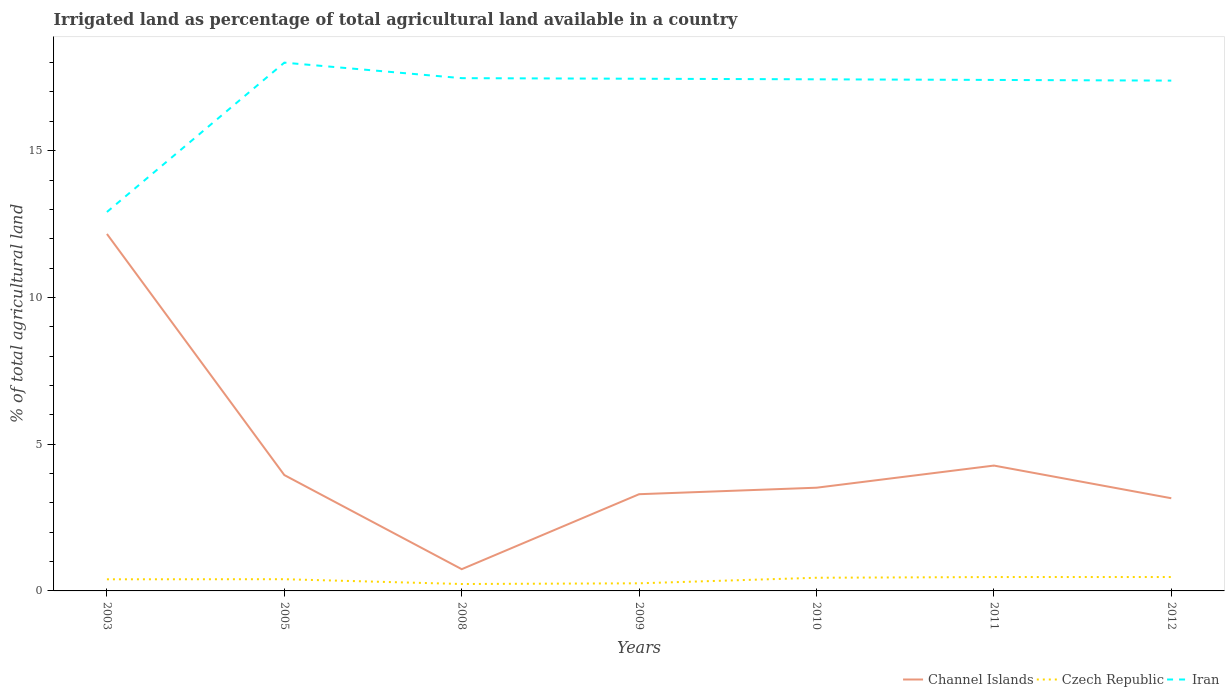Does the line corresponding to Czech Republic intersect with the line corresponding to Channel Islands?
Offer a terse response. No. Across all years, what is the maximum percentage of irrigated land in Czech Republic?
Provide a short and direct response. 0.24. In which year was the percentage of irrigated land in Channel Islands maximum?
Your response must be concise. 2008. What is the total percentage of irrigated land in Channel Islands in the graph?
Your response must be concise. -2.55. What is the difference between the highest and the second highest percentage of irrigated land in Czech Republic?
Provide a succinct answer. 0.24. Is the percentage of irrigated land in Czech Republic strictly greater than the percentage of irrigated land in Iran over the years?
Offer a very short reply. Yes. How many lines are there?
Offer a very short reply. 3. What is the difference between two consecutive major ticks on the Y-axis?
Provide a succinct answer. 5. Does the graph contain grids?
Your response must be concise. No. How many legend labels are there?
Offer a very short reply. 3. How are the legend labels stacked?
Offer a terse response. Horizontal. What is the title of the graph?
Your answer should be compact. Irrigated land as percentage of total agricultural land available in a country. Does "Morocco" appear as one of the legend labels in the graph?
Provide a short and direct response. No. What is the label or title of the Y-axis?
Offer a terse response. % of total agricultural land. What is the % of total agricultural land of Channel Islands in 2003?
Ensure brevity in your answer.  12.16. What is the % of total agricultural land in Czech Republic in 2003?
Provide a short and direct response. 0.4. What is the % of total agricultural land of Iran in 2003?
Your answer should be very brief. 12.91. What is the % of total agricultural land in Channel Islands in 2005?
Give a very brief answer. 3.95. What is the % of total agricultural land in Czech Republic in 2005?
Your answer should be compact. 0.4. What is the % of total agricultural land in Iran in 2005?
Provide a short and direct response. 18. What is the % of total agricultural land of Channel Islands in 2008?
Ensure brevity in your answer.  0.74. What is the % of total agricultural land in Czech Republic in 2008?
Give a very brief answer. 0.24. What is the % of total agricultural land of Iran in 2008?
Ensure brevity in your answer.  17.47. What is the % of total agricultural land in Channel Islands in 2009?
Ensure brevity in your answer.  3.3. What is the % of total agricultural land in Czech Republic in 2009?
Keep it short and to the point. 0.26. What is the % of total agricultural land in Iran in 2009?
Your response must be concise. 17.45. What is the % of total agricultural land of Channel Islands in 2010?
Keep it short and to the point. 3.52. What is the % of total agricultural land in Czech Republic in 2010?
Offer a very short reply. 0.45. What is the % of total agricultural land in Iran in 2010?
Provide a succinct answer. 17.43. What is the % of total agricultural land in Channel Islands in 2011?
Provide a short and direct response. 4.27. What is the % of total agricultural land of Czech Republic in 2011?
Your answer should be very brief. 0.47. What is the % of total agricultural land in Iran in 2011?
Ensure brevity in your answer.  17.41. What is the % of total agricultural land of Channel Islands in 2012?
Your answer should be compact. 3.16. What is the % of total agricultural land in Czech Republic in 2012?
Provide a succinct answer. 0.47. What is the % of total agricultural land in Iran in 2012?
Give a very brief answer. 17.39. Across all years, what is the maximum % of total agricultural land of Channel Islands?
Keep it short and to the point. 12.16. Across all years, what is the maximum % of total agricultural land of Czech Republic?
Your answer should be very brief. 0.47. Across all years, what is the maximum % of total agricultural land in Iran?
Ensure brevity in your answer.  18. Across all years, what is the minimum % of total agricultural land of Channel Islands?
Offer a terse response. 0.74. Across all years, what is the minimum % of total agricultural land of Czech Republic?
Your response must be concise. 0.24. Across all years, what is the minimum % of total agricultural land in Iran?
Offer a very short reply. 12.91. What is the total % of total agricultural land of Channel Islands in the graph?
Your response must be concise. 31.09. What is the total % of total agricultural land in Czech Republic in the graph?
Keep it short and to the point. 2.69. What is the total % of total agricultural land in Iran in the graph?
Offer a very short reply. 118.06. What is the difference between the % of total agricultural land of Channel Islands in 2003 and that in 2005?
Make the answer very short. 8.21. What is the difference between the % of total agricultural land of Czech Republic in 2003 and that in 2005?
Your answer should be compact. -0. What is the difference between the % of total agricultural land of Iran in 2003 and that in 2005?
Ensure brevity in your answer.  -5.09. What is the difference between the % of total agricultural land in Channel Islands in 2003 and that in 2008?
Ensure brevity in your answer.  11.42. What is the difference between the % of total agricultural land in Czech Republic in 2003 and that in 2008?
Keep it short and to the point. 0.16. What is the difference between the % of total agricultural land of Iran in 2003 and that in 2008?
Give a very brief answer. -4.56. What is the difference between the % of total agricultural land in Channel Islands in 2003 and that in 2009?
Ensure brevity in your answer.  8.87. What is the difference between the % of total agricultural land in Czech Republic in 2003 and that in 2009?
Give a very brief answer. 0.14. What is the difference between the % of total agricultural land in Iran in 2003 and that in 2009?
Provide a succinct answer. -4.54. What is the difference between the % of total agricultural land of Channel Islands in 2003 and that in 2010?
Ensure brevity in your answer.  8.65. What is the difference between the % of total agricultural land of Czech Republic in 2003 and that in 2010?
Your answer should be very brief. -0.05. What is the difference between the % of total agricultural land of Iran in 2003 and that in 2010?
Your response must be concise. -4.52. What is the difference between the % of total agricultural land of Channel Islands in 2003 and that in 2011?
Make the answer very short. 7.89. What is the difference between the % of total agricultural land in Czech Republic in 2003 and that in 2011?
Give a very brief answer. -0.08. What is the difference between the % of total agricultural land of Iran in 2003 and that in 2011?
Ensure brevity in your answer.  -4.5. What is the difference between the % of total agricultural land in Channel Islands in 2003 and that in 2012?
Offer a very short reply. 9. What is the difference between the % of total agricultural land in Czech Republic in 2003 and that in 2012?
Provide a succinct answer. -0.08. What is the difference between the % of total agricultural land in Iran in 2003 and that in 2012?
Provide a short and direct response. -4.48. What is the difference between the % of total agricultural land in Channel Islands in 2005 and that in 2008?
Provide a succinct answer. 3.21. What is the difference between the % of total agricultural land in Czech Republic in 2005 and that in 2008?
Make the answer very short. 0.16. What is the difference between the % of total agricultural land in Iran in 2005 and that in 2008?
Ensure brevity in your answer.  0.53. What is the difference between the % of total agricultural land of Channel Islands in 2005 and that in 2009?
Give a very brief answer. 0.65. What is the difference between the % of total agricultural land in Czech Republic in 2005 and that in 2009?
Provide a succinct answer. 0.14. What is the difference between the % of total agricultural land in Iran in 2005 and that in 2009?
Provide a succinct answer. 0.55. What is the difference between the % of total agricultural land in Channel Islands in 2005 and that in 2010?
Your answer should be compact. 0.43. What is the difference between the % of total agricultural land of Czech Republic in 2005 and that in 2010?
Give a very brief answer. -0.05. What is the difference between the % of total agricultural land of Iran in 2005 and that in 2010?
Keep it short and to the point. 0.57. What is the difference between the % of total agricultural land in Channel Islands in 2005 and that in 2011?
Offer a terse response. -0.32. What is the difference between the % of total agricultural land of Czech Republic in 2005 and that in 2011?
Offer a very short reply. -0.07. What is the difference between the % of total agricultural land in Iran in 2005 and that in 2011?
Your answer should be very brief. 0.59. What is the difference between the % of total agricultural land of Channel Islands in 2005 and that in 2012?
Ensure brevity in your answer.  0.79. What is the difference between the % of total agricultural land of Czech Republic in 2005 and that in 2012?
Give a very brief answer. -0.07. What is the difference between the % of total agricultural land in Iran in 2005 and that in 2012?
Offer a terse response. 0.61. What is the difference between the % of total agricultural land of Channel Islands in 2008 and that in 2009?
Make the answer very short. -2.55. What is the difference between the % of total agricultural land of Czech Republic in 2008 and that in 2009?
Offer a terse response. -0.02. What is the difference between the % of total agricultural land in Iran in 2008 and that in 2009?
Offer a terse response. 0.02. What is the difference between the % of total agricultural land of Channel Islands in 2008 and that in 2010?
Your answer should be compact. -2.78. What is the difference between the % of total agricultural land of Czech Republic in 2008 and that in 2010?
Give a very brief answer. -0.21. What is the difference between the % of total agricultural land in Iran in 2008 and that in 2010?
Make the answer very short. 0.04. What is the difference between the % of total agricultural land of Channel Islands in 2008 and that in 2011?
Provide a short and direct response. -3.53. What is the difference between the % of total agricultural land in Czech Republic in 2008 and that in 2011?
Offer a terse response. -0.24. What is the difference between the % of total agricultural land of Iran in 2008 and that in 2011?
Your answer should be very brief. 0.06. What is the difference between the % of total agricultural land in Channel Islands in 2008 and that in 2012?
Provide a short and direct response. -2.42. What is the difference between the % of total agricultural land of Czech Republic in 2008 and that in 2012?
Keep it short and to the point. -0.24. What is the difference between the % of total agricultural land in Iran in 2008 and that in 2012?
Your answer should be compact. 0.08. What is the difference between the % of total agricultural land of Channel Islands in 2009 and that in 2010?
Make the answer very short. -0.22. What is the difference between the % of total agricultural land in Czech Republic in 2009 and that in 2010?
Offer a very short reply. -0.19. What is the difference between the % of total agricultural land in Iran in 2009 and that in 2010?
Provide a short and direct response. 0.02. What is the difference between the % of total agricultural land of Channel Islands in 2009 and that in 2011?
Give a very brief answer. -0.98. What is the difference between the % of total agricultural land in Czech Republic in 2009 and that in 2011?
Provide a short and direct response. -0.21. What is the difference between the % of total agricultural land of Iran in 2009 and that in 2011?
Give a very brief answer. 0.04. What is the difference between the % of total agricultural land of Channel Islands in 2009 and that in 2012?
Keep it short and to the point. 0.14. What is the difference between the % of total agricultural land in Czech Republic in 2009 and that in 2012?
Give a very brief answer. -0.21. What is the difference between the % of total agricultural land of Iran in 2009 and that in 2012?
Offer a very short reply. 0.06. What is the difference between the % of total agricultural land of Channel Islands in 2010 and that in 2011?
Your answer should be compact. -0.75. What is the difference between the % of total agricultural land of Czech Republic in 2010 and that in 2011?
Offer a very short reply. -0.02. What is the difference between the % of total agricultural land in Iran in 2010 and that in 2011?
Offer a terse response. 0.02. What is the difference between the % of total agricultural land in Channel Islands in 2010 and that in 2012?
Offer a very short reply. 0.36. What is the difference between the % of total agricultural land in Czech Republic in 2010 and that in 2012?
Keep it short and to the point. -0.02. What is the difference between the % of total agricultural land in Iran in 2010 and that in 2012?
Ensure brevity in your answer.  0.04. What is the difference between the % of total agricultural land of Channel Islands in 2011 and that in 2012?
Offer a terse response. 1.11. What is the difference between the % of total agricultural land of Czech Republic in 2011 and that in 2012?
Offer a terse response. -0. What is the difference between the % of total agricultural land of Iran in 2011 and that in 2012?
Your response must be concise. 0.02. What is the difference between the % of total agricultural land of Channel Islands in 2003 and the % of total agricultural land of Czech Republic in 2005?
Keep it short and to the point. 11.76. What is the difference between the % of total agricultural land of Channel Islands in 2003 and the % of total agricultural land of Iran in 2005?
Keep it short and to the point. -5.84. What is the difference between the % of total agricultural land in Czech Republic in 2003 and the % of total agricultural land in Iran in 2005?
Your response must be concise. -17.6. What is the difference between the % of total agricultural land in Channel Islands in 2003 and the % of total agricultural land in Czech Republic in 2008?
Make the answer very short. 11.93. What is the difference between the % of total agricultural land in Channel Islands in 2003 and the % of total agricultural land in Iran in 2008?
Offer a very short reply. -5.31. What is the difference between the % of total agricultural land of Czech Republic in 2003 and the % of total agricultural land of Iran in 2008?
Offer a very short reply. -17.07. What is the difference between the % of total agricultural land in Channel Islands in 2003 and the % of total agricultural land in Czech Republic in 2009?
Give a very brief answer. 11.9. What is the difference between the % of total agricultural land in Channel Islands in 2003 and the % of total agricultural land in Iran in 2009?
Offer a very short reply. -5.29. What is the difference between the % of total agricultural land in Czech Republic in 2003 and the % of total agricultural land in Iran in 2009?
Offer a very short reply. -17.05. What is the difference between the % of total agricultural land in Channel Islands in 2003 and the % of total agricultural land in Czech Republic in 2010?
Your answer should be very brief. 11.71. What is the difference between the % of total agricultural land in Channel Islands in 2003 and the % of total agricultural land in Iran in 2010?
Provide a succinct answer. -5.27. What is the difference between the % of total agricultural land in Czech Republic in 2003 and the % of total agricultural land in Iran in 2010?
Provide a short and direct response. -17.04. What is the difference between the % of total agricultural land of Channel Islands in 2003 and the % of total agricultural land of Czech Republic in 2011?
Your answer should be very brief. 11.69. What is the difference between the % of total agricultural land of Channel Islands in 2003 and the % of total agricultural land of Iran in 2011?
Provide a succinct answer. -5.25. What is the difference between the % of total agricultural land in Czech Republic in 2003 and the % of total agricultural land in Iran in 2011?
Ensure brevity in your answer.  -17.01. What is the difference between the % of total agricultural land in Channel Islands in 2003 and the % of total agricultural land in Czech Republic in 2012?
Offer a very short reply. 11.69. What is the difference between the % of total agricultural land in Channel Islands in 2003 and the % of total agricultural land in Iran in 2012?
Ensure brevity in your answer.  -5.22. What is the difference between the % of total agricultural land of Czech Republic in 2003 and the % of total agricultural land of Iran in 2012?
Provide a succinct answer. -16.99. What is the difference between the % of total agricultural land in Channel Islands in 2005 and the % of total agricultural land in Czech Republic in 2008?
Your answer should be compact. 3.71. What is the difference between the % of total agricultural land of Channel Islands in 2005 and the % of total agricultural land of Iran in 2008?
Your answer should be compact. -13.52. What is the difference between the % of total agricultural land in Czech Republic in 2005 and the % of total agricultural land in Iran in 2008?
Provide a succinct answer. -17.07. What is the difference between the % of total agricultural land of Channel Islands in 2005 and the % of total agricultural land of Czech Republic in 2009?
Provide a short and direct response. 3.69. What is the difference between the % of total agricultural land of Channel Islands in 2005 and the % of total agricultural land of Iran in 2009?
Your answer should be very brief. -13.5. What is the difference between the % of total agricultural land in Czech Republic in 2005 and the % of total agricultural land in Iran in 2009?
Your response must be concise. -17.05. What is the difference between the % of total agricultural land in Channel Islands in 2005 and the % of total agricultural land in Czech Republic in 2010?
Offer a very short reply. 3.5. What is the difference between the % of total agricultural land of Channel Islands in 2005 and the % of total agricultural land of Iran in 2010?
Your response must be concise. -13.48. What is the difference between the % of total agricultural land in Czech Republic in 2005 and the % of total agricultural land in Iran in 2010?
Provide a short and direct response. -17.03. What is the difference between the % of total agricultural land of Channel Islands in 2005 and the % of total agricultural land of Czech Republic in 2011?
Make the answer very short. 3.47. What is the difference between the % of total agricultural land of Channel Islands in 2005 and the % of total agricultural land of Iran in 2011?
Provide a short and direct response. -13.46. What is the difference between the % of total agricultural land of Czech Republic in 2005 and the % of total agricultural land of Iran in 2011?
Your response must be concise. -17.01. What is the difference between the % of total agricultural land of Channel Islands in 2005 and the % of total agricultural land of Czech Republic in 2012?
Provide a short and direct response. 3.47. What is the difference between the % of total agricultural land of Channel Islands in 2005 and the % of total agricultural land of Iran in 2012?
Your answer should be compact. -13.44. What is the difference between the % of total agricultural land of Czech Republic in 2005 and the % of total agricultural land of Iran in 2012?
Offer a very short reply. -16.99. What is the difference between the % of total agricultural land in Channel Islands in 2008 and the % of total agricultural land in Czech Republic in 2009?
Your answer should be very brief. 0.48. What is the difference between the % of total agricultural land in Channel Islands in 2008 and the % of total agricultural land in Iran in 2009?
Make the answer very short. -16.71. What is the difference between the % of total agricultural land of Czech Republic in 2008 and the % of total agricultural land of Iran in 2009?
Provide a short and direct response. -17.21. What is the difference between the % of total agricultural land in Channel Islands in 2008 and the % of total agricultural land in Czech Republic in 2010?
Your answer should be compact. 0.29. What is the difference between the % of total agricultural land in Channel Islands in 2008 and the % of total agricultural land in Iran in 2010?
Provide a short and direct response. -16.69. What is the difference between the % of total agricultural land in Czech Republic in 2008 and the % of total agricultural land in Iran in 2010?
Ensure brevity in your answer.  -17.2. What is the difference between the % of total agricultural land of Channel Islands in 2008 and the % of total agricultural land of Czech Republic in 2011?
Keep it short and to the point. 0.27. What is the difference between the % of total agricultural land of Channel Islands in 2008 and the % of total agricultural land of Iran in 2011?
Your response must be concise. -16.67. What is the difference between the % of total agricultural land of Czech Republic in 2008 and the % of total agricultural land of Iran in 2011?
Your answer should be very brief. -17.17. What is the difference between the % of total agricultural land in Channel Islands in 2008 and the % of total agricultural land in Czech Republic in 2012?
Your response must be concise. 0.27. What is the difference between the % of total agricultural land in Channel Islands in 2008 and the % of total agricultural land in Iran in 2012?
Keep it short and to the point. -16.65. What is the difference between the % of total agricultural land of Czech Republic in 2008 and the % of total agricultural land of Iran in 2012?
Provide a succinct answer. -17.15. What is the difference between the % of total agricultural land of Channel Islands in 2009 and the % of total agricultural land of Czech Republic in 2010?
Ensure brevity in your answer.  2.85. What is the difference between the % of total agricultural land in Channel Islands in 2009 and the % of total agricultural land in Iran in 2010?
Ensure brevity in your answer.  -14.14. What is the difference between the % of total agricultural land of Czech Republic in 2009 and the % of total agricultural land of Iran in 2010?
Ensure brevity in your answer.  -17.17. What is the difference between the % of total agricultural land of Channel Islands in 2009 and the % of total agricultural land of Czech Republic in 2011?
Your response must be concise. 2.82. What is the difference between the % of total agricultural land in Channel Islands in 2009 and the % of total agricultural land in Iran in 2011?
Your answer should be very brief. -14.11. What is the difference between the % of total agricultural land in Czech Republic in 2009 and the % of total agricultural land in Iran in 2011?
Keep it short and to the point. -17.15. What is the difference between the % of total agricultural land in Channel Islands in 2009 and the % of total agricultural land in Czech Republic in 2012?
Your answer should be very brief. 2.82. What is the difference between the % of total agricultural land of Channel Islands in 2009 and the % of total agricultural land of Iran in 2012?
Give a very brief answer. -14.09. What is the difference between the % of total agricultural land of Czech Republic in 2009 and the % of total agricultural land of Iran in 2012?
Your response must be concise. -17.13. What is the difference between the % of total agricultural land in Channel Islands in 2010 and the % of total agricultural land in Czech Republic in 2011?
Your answer should be compact. 3.04. What is the difference between the % of total agricultural land in Channel Islands in 2010 and the % of total agricultural land in Iran in 2011?
Provide a short and direct response. -13.89. What is the difference between the % of total agricultural land in Czech Republic in 2010 and the % of total agricultural land in Iran in 2011?
Offer a very short reply. -16.96. What is the difference between the % of total agricultural land of Channel Islands in 2010 and the % of total agricultural land of Czech Republic in 2012?
Your response must be concise. 3.04. What is the difference between the % of total agricultural land in Channel Islands in 2010 and the % of total agricultural land in Iran in 2012?
Provide a short and direct response. -13.87. What is the difference between the % of total agricultural land in Czech Republic in 2010 and the % of total agricultural land in Iran in 2012?
Give a very brief answer. -16.94. What is the difference between the % of total agricultural land of Channel Islands in 2011 and the % of total agricultural land of Czech Republic in 2012?
Give a very brief answer. 3.8. What is the difference between the % of total agricultural land in Channel Islands in 2011 and the % of total agricultural land in Iran in 2012?
Make the answer very short. -13.12. What is the difference between the % of total agricultural land in Czech Republic in 2011 and the % of total agricultural land in Iran in 2012?
Your answer should be compact. -16.91. What is the average % of total agricultural land in Channel Islands per year?
Give a very brief answer. 4.44. What is the average % of total agricultural land in Czech Republic per year?
Make the answer very short. 0.38. What is the average % of total agricultural land in Iran per year?
Keep it short and to the point. 16.87. In the year 2003, what is the difference between the % of total agricultural land in Channel Islands and % of total agricultural land in Czech Republic?
Give a very brief answer. 11.77. In the year 2003, what is the difference between the % of total agricultural land in Channel Islands and % of total agricultural land in Iran?
Your answer should be compact. -0.75. In the year 2003, what is the difference between the % of total agricultural land of Czech Republic and % of total agricultural land of Iran?
Provide a short and direct response. -12.51. In the year 2005, what is the difference between the % of total agricultural land in Channel Islands and % of total agricultural land in Czech Republic?
Provide a succinct answer. 3.55. In the year 2005, what is the difference between the % of total agricultural land in Channel Islands and % of total agricultural land in Iran?
Provide a short and direct response. -14.05. In the year 2005, what is the difference between the % of total agricultural land in Czech Republic and % of total agricultural land in Iran?
Keep it short and to the point. -17.6. In the year 2008, what is the difference between the % of total agricultural land of Channel Islands and % of total agricultural land of Czech Republic?
Ensure brevity in your answer.  0.51. In the year 2008, what is the difference between the % of total agricultural land of Channel Islands and % of total agricultural land of Iran?
Provide a short and direct response. -16.73. In the year 2008, what is the difference between the % of total agricultural land of Czech Republic and % of total agricultural land of Iran?
Offer a very short reply. -17.23. In the year 2009, what is the difference between the % of total agricultural land in Channel Islands and % of total agricultural land in Czech Republic?
Your answer should be compact. 3.04. In the year 2009, what is the difference between the % of total agricultural land of Channel Islands and % of total agricultural land of Iran?
Offer a terse response. -14.15. In the year 2009, what is the difference between the % of total agricultural land in Czech Republic and % of total agricultural land in Iran?
Offer a terse response. -17.19. In the year 2010, what is the difference between the % of total agricultural land in Channel Islands and % of total agricultural land in Czech Republic?
Your answer should be compact. 3.07. In the year 2010, what is the difference between the % of total agricultural land in Channel Islands and % of total agricultural land in Iran?
Your answer should be compact. -13.91. In the year 2010, what is the difference between the % of total agricultural land of Czech Republic and % of total agricultural land of Iran?
Your answer should be very brief. -16.98. In the year 2011, what is the difference between the % of total agricultural land in Channel Islands and % of total agricultural land in Czech Republic?
Ensure brevity in your answer.  3.8. In the year 2011, what is the difference between the % of total agricultural land of Channel Islands and % of total agricultural land of Iran?
Make the answer very short. -13.14. In the year 2011, what is the difference between the % of total agricultural land in Czech Republic and % of total agricultural land in Iran?
Your answer should be very brief. -16.94. In the year 2012, what is the difference between the % of total agricultural land in Channel Islands and % of total agricultural land in Czech Republic?
Ensure brevity in your answer.  2.68. In the year 2012, what is the difference between the % of total agricultural land of Channel Islands and % of total agricultural land of Iran?
Your response must be concise. -14.23. In the year 2012, what is the difference between the % of total agricultural land in Czech Republic and % of total agricultural land in Iran?
Give a very brief answer. -16.91. What is the ratio of the % of total agricultural land of Channel Islands in 2003 to that in 2005?
Offer a very short reply. 3.08. What is the ratio of the % of total agricultural land in Iran in 2003 to that in 2005?
Offer a terse response. 0.72. What is the ratio of the % of total agricultural land in Channel Islands in 2003 to that in 2008?
Offer a very short reply. 16.42. What is the ratio of the % of total agricultural land in Czech Republic in 2003 to that in 2008?
Offer a very short reply. 1.68. What is the ratio of the % of total agricultural land of Iran in 2003 to that in 2008?
Offer a terse response. 0.74. What is the ratio of the % of total agricultural land in Channel Islands in 2003 to that in 2009?
Make the answer very short. 3.69. What is the ratio of the % of total agricultural land of Czech Republic in 2003 to that in 2009?
Keep it short and to the point. 1.53. What is the ratio of the % of total agricultural land of Iran in 2003 to that in 2009?
Your response must be concise. 0.74. What is the ratio of the % of total agricultural land of Channel Islands in 2003 to that in 2010?
Provide a succinct answer. 3.46. What is the ratio of the % of total agricultural land in Czech Republic in 2003 to that in 2010?
Provide a short and direct response. 0.88. What is the ratio of the % of total agricultural land in Iran in 2003 to that in 2010?
Keep it short and to the point. 0.74. What is the ratio of the % of total agricultural land in Channel Islands in 2003 to that in 2011?
Give a very brief answer. 2.85. What is the ratio of the % of total agricultural land in Czech Republic in 2003 to that in 2011?
Keep it short and to the point. 0.84. What is the ratio of the % of total agricultural land of Iran in 2003 to that in 2011?
Your answer should be compact. 0.74. What is the ratio of the % of total agricultural land in Channel Islands in 2003 to that in 2012?
Give a very brief answer. 3.85. What is the ratio of the % of total agricultural land in Czech Republic in 2003 to that in 2012?
Offer a very short reply. 0.84. What is the ratio of the % of total agricultural land in Iran in 2003 to that in 2012?
Your answer should be compact. 0.74. What is the ratio of the % of total agricultural land in Channel Islands in 2005 to that in 2008?
Provide a short and direct response. 5.33. What is the ratio of the % of total agricultural land in Czech Republic in 2005 to that in 2008?
Keep it short and to the point. 1.69. What is the ratio of the % of total agricultural land of Iran in 2005 to that in 2008?
Offer a terse response. 1.03. What is the ratio of the % of total agricultural land of Channel Islands in 2005 to that in 2009?
Your answer should be compact. 1.2. What is the ratio of the % of total agricultural land of Czech Republic in 2005 to that in 2009?
Make the answer very short. 1.54. What is the ratio of the % of total agricultural land of Iran in 2005 to that in 2009?
Your response must be concise. 1.03. What is the ratio of the % of total agricultural land in Channel Islands in 2005 to that in 2010?
Give a very brief answer. 1.12. What is the ratio of the % of total agricultural land in Czech Republic in 2005 to that in 2010?
Ensure brevity in your answer.  0.89. What is the ratio of the % of total agricultural land of Iran in 2005 to that in 2010?
Offer a very short reply. 1.03. What is the ratio of the % of total agricultural land of Channel Islands in 2005 to that in 2011?
Your response must be concise. 0.92. What is the ratio of the % of total agricultural land of Czech Republic in 2005 to that in 2011?
Your response must be concise. 0.84. What is the ratio of the % of total agricultural land in Iran in 2005 to that in 2011?
Keep it short and to the point. 1.03. What is the ratio of the % of total agricultural land of Channel Islands in 2005 to that in 2012?
Make the answer very short. 1.25. What is the ratio of the % of total agricultural land of Czech Republic in 2005 to that in 2012?
Provide a short and direct response. 0.84. What is the ratio of the % of total agricultural land of Iran in 2005 to that in 2012?
Offer a terse response. 1.04. What is the ratio of the % of total agricultural land of Channel Islands in 2008 to that in 2009?
Make the answer very short. 0.22. What is the ratio of the % of total agricultural land of Czech Republic in 2008 to that in 2009?
Make the answer very short. 0.91. What is the ratio of the % of total agricultural land of Iran in 2008 to that in 2009?
Your response must be concise. 1. What is the ratio of the % of total agricultural land of Channel Islands in 2008 to that in 2010?
Your answer should be very brief. 0.21. What is the ratio of the % of total agricultural land of Czech Republic in 2008 to that in 2010?
Your answer should be very brief. 0.53. What is the ratio of the % of total agricultural land in Channel Islands in 2008 to that in 2011?
Offer a terse response. 0.17. What is the ratio of the % of total agricultural land of Czech Republic in 2008 to that in 2011?
Provide a succinct answer. 0.5. What is the ratio of the % of total agricultural land in Iran in 2008 to that in 2011?
Your response must be concise. 1. What is the ratio of the % of total agricultural land of Channel Islands in 2008 to that in 2012?
Keep it short and to the point. 0.23. What is the ratio of the % of total agricultural land of Czech Republic in 2008 to that in 2012?
Offer a terse response. 0.5. What is the ratio of the % of total agricultural land in Iran in 2008 to that in 2012?
Your answer should be very brief. 1. What is the ratio of the % of total agricultural land of Channel Islands in 2009 to that in 2010?
Offer a very short reply. 0.94. What is the ratio of the % of total agricultural land of Czech Republic in 2009 to that in 2010?
Give a very brief answer. 0.58. What is the ratio of the % of total agricultural land of Iran in 2009 to that in 2010?
Provide a succinct answer. 1. What is the ratio of the % of total agricultural land of Channel Islands in 2009 to that in 2011?
Your answer should be very brief. 0.77. What is the ratio of the % of total agricultural land of Czech Republic in 2009 to that in 2011?
Give a very brief answer. 0.55. What is the ratio of the % of total agricultural land in Channel Islands in 2009 to that in 2012?
Your answer should be compact. 1.04. What is the ratio of the % of total agricultural land of Czech Republic in 2009 to that in 2012?
Offer a very short reply. 0.55. What is the ratio of the % of total agricultural land of Channel Islands in 2010 to that in 2011?
Offer a terse response. 0.82. What is the ratio of the % of total agricultural land in Czech Republic in 2010 to that in 2011?
Your answer should be compact. 0.95. What is the ratio of the % of total agricultural land in Iran in 2010 to that in 2011?
Keep it short and to the point. 1. What is the ratio of the % of total agricultural land of Channel Islands in 2010 to that in 2012?
Offer a terse response. 1.11. What is the ratio of the % of total agricultural land in Czech Republic in 2010 to that in 2012?
Provide a succinct answer. 0.95. What is the ratio of the % of total agricultural land in Channel Islands in 2011 to that in 2012?
Offer a terse response. 1.35. What is the ratio of the % of total agricultural land in Czech Republic in 2011 to that in 2012?
Provide a short and direct response. 1. What is the ratio of the % of total agricultural land in Iran in 2011 to that in 2012?
Your answer should be compact. 1. What is the difference between the highest and the second highest % of total agricultural land of Channel Islands?
Your response must be concise. 7.89. What is the difference between the highest and the second highest % of total agricultural land in Iran?
Give a very brief answer. 0.53. What is the difference between the highest and the lowest % of total agricultural land in Channel Islands?
Ensure brevity in your answer.  11.42. What is the difference between the highest and the lowest % of total agricultural land of Czech Republic?
Your answer should be very brief. 0.24. What is the difference between the highest and the lowest % of total agricultural land in Iran?
Provide a succinct answer. 5.09. 